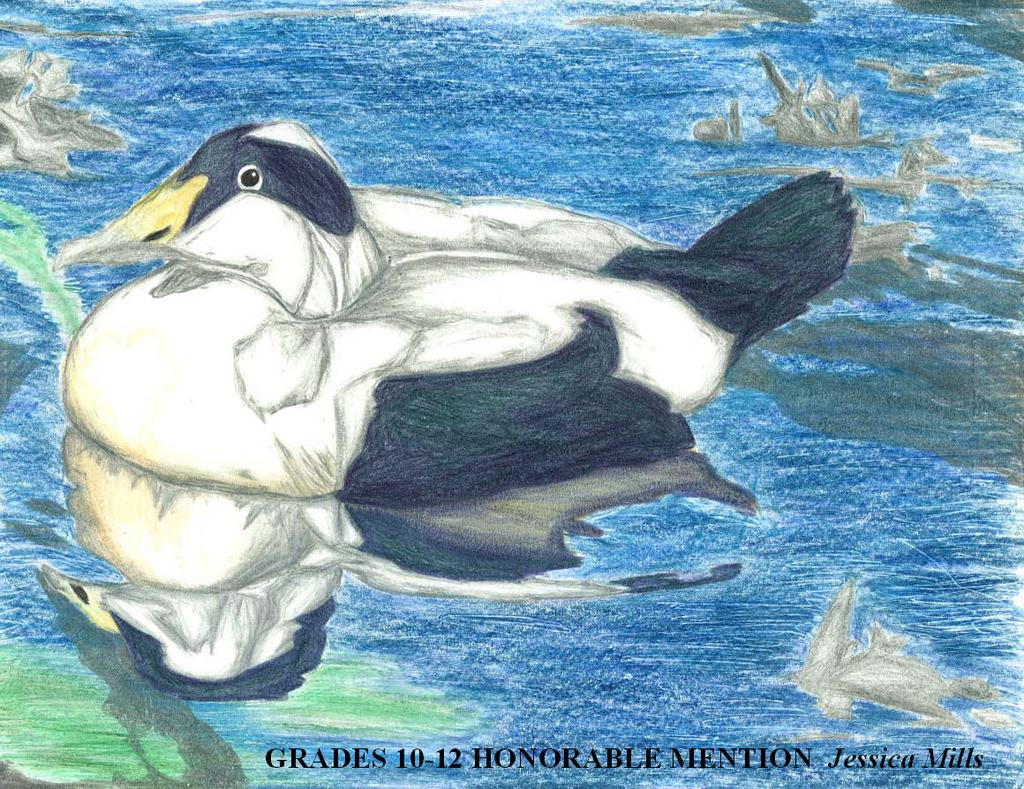What is depicted in the painting in the image? There is a painting of a duck in the image. Where is the duck located in the painting? The duck is in the water. What additional information is provided at the bottom of the image? There is text at the bottom of the image. What type of wound can be seen on the duck's arm in the image? There is no wound or arm visible on the duck in the image, as it is a painting of a duck in the water. 